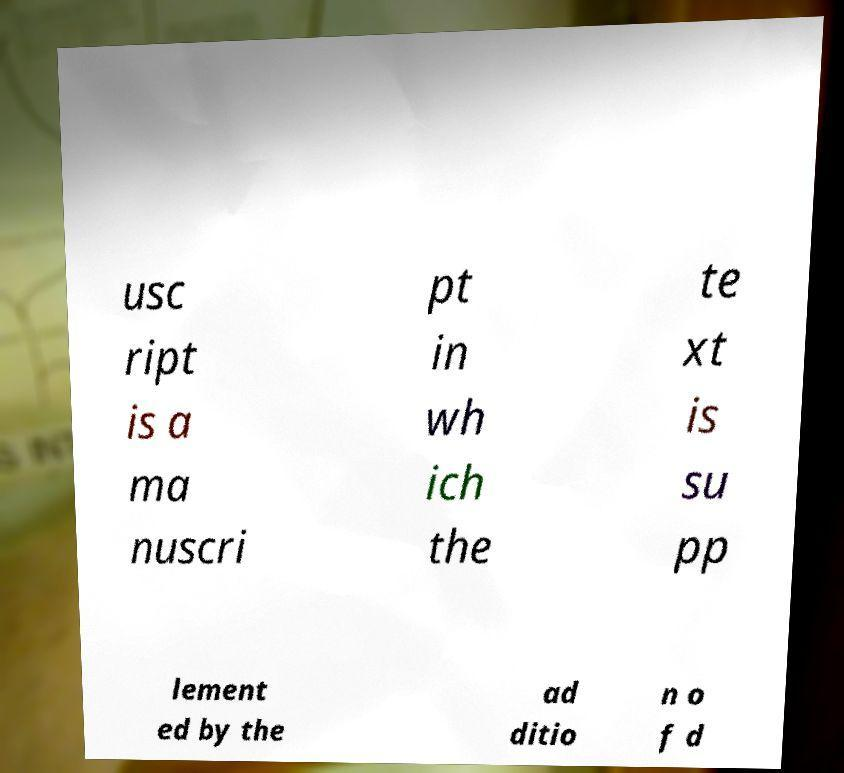I need the written content from this picture converted into text. Can you do that? usc ript is a ma nuscri pt in wh ich the te xt is su pp lement ed by the ad ditio n o f d 